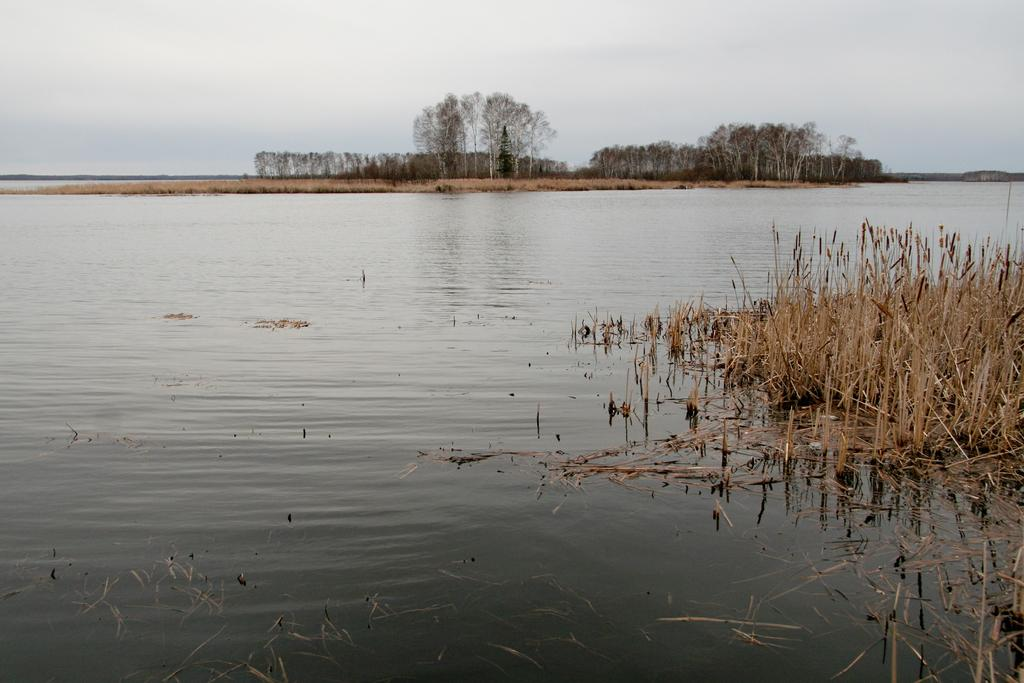What type of vegetation can be seen in the image? There are trees in the image. What is the condition of the ground in the image? There is dry grass in the image. What can be seen in the image besides the trees and dry grass? There is water visible in the image. What is visible in the background of the image? The sky is visible in the image. How many bells are hanging from the trees in the image? There are no bells present in the image; it only features trees, dry grass, water, and the sky. Can you tell me which guide is leading the team in the image? There is no guide or team present in the image; it only features natural elements like trees, dry grass, water, and the sky. 